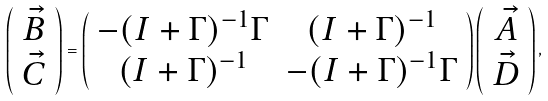Convert formula to latex. <formula><loc_0><loc_0><loc_500><loc_500>\left ( \begin{array} { c } \vec { B } \\ \vec { C } \end{array} \right ) = \left ( \begin{array} { c c } - ( I + \Gamma ) ^ { - 1 } \Gamma & ( I + \Gamma ) ^ { - 1 } \\ ( I + \Gamma ) ^ { - 1 } & - ( I + \Gamma ) ^ { - 1 } \Gamma \end{array} \right ) \left ( \begin{array} { c } \vec { A } \\ \vec { D } \end{array} \right ) ,</formula> 